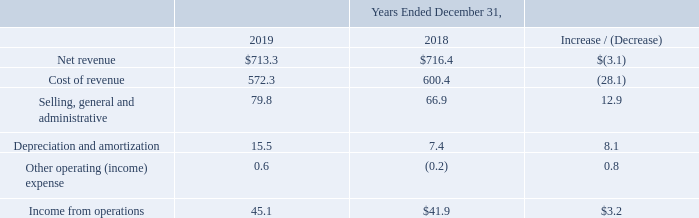Segment Results of Operations In the Company's Consolidated Financial Statements, other operating (income) expense includes (i) (gain) loss on sale or disposal of assets, (ii) lease termination costs, (iii) asset impairment expense, (iv) accretion of asset retirement obligations, and (v) FCC reimbursements. Each table summarizes the results of operations of our operating segments and compares the amount of the change between the periods presented (in millions).
Net revenue: Net revenue from our Construction segment for the year ended December 31, 2019 decreased $3.1 million to $713.3 million from $716.4 million for the year ended December 31, 2018. The decrease was primarily driven by lower revenues from our structural steel fabrication and erection business, which had increased activity in the comparable period on certain large commercial construction projects that are now at or near completion in the current period. This was largely offset by DBMG’s acquisition of GrayWolf, which was acquired late in the fourth quarter of 2018, and from higher revenues from our construction modeling and detailing business as a result of an increase in project work.
Cost of revenue: Cost of revenue from our Construction segment for the year ended December 31, 2019 decreased $28.1 million to $572.3 million from $600.4 million for the year ended December 31, 2018. The decrease was primarily driven by the timing of project activity on certain large commercial construction projects that are now at or near completion in the current period. This was partially offset by costs associated with the construction modeling and detailing business as a result of an increase in project work and increases as a result of the acquisition of GrayWolf, which was acquired late in the fourth quarter of 2018.
Selling, general and administrative: Selling, general and administrative expenses from our Construction segment for the year ended December 31, 2019 increased $12.9 million to $79.8 million from $66.9 million for the year ended December 31, 2018. The increase was primarily due to headcount-driven increases in salary and benefits and an increase in operating expenses as a result of the acquisition of GrayWolf, which was acquired late in the fourth quarter of 2018.
Depreciation and amortization: Depreciation and amortization from our Construction segment for the year ended December 31, 2019 increased $8.1 million to $15.5 million from $7.4 million for the year ended December 31, 2018. The increase was due to amortization of intangibles obtained through the acquisition of GrayWolf and assets placed into service in 2019.
Other operating (income) expense: Other operating (income) expense from our Construction segment for the year ended December 31, 2019 decreased by $0.8 million to a loss of $0.6 million from income of $0.2 million for the year ended December 31, 2018. The change was primarily due to the gains and losses on the sale of land and assets in the comparable periods.
What was the net revenue from Marine Services segment for the year ended December 31, 2019? $713.3 million. What was the net revenue from Marine Services segment for the year ended December 31, 2018? $716.4 million. What was the cost of revenue from Marine Services segment for the year ended December 31, 2019? $572.3 million. What was the percentage increase / (decrease) in the net revenue from 2018 to 2019?
Answer scale should be: percent. 713.3 / 716.4 - 1
Answer: -0.43. What was the average cost of revenue?
Answer scale should be: million. (572.3 + 600.4) / 2
Answer: 586.35. What is the percentage increase / (decrease) in the Depreciation and amortization from 2018 to 2019?
Answer scale should be: percent. (15.5 / 7.4 - 1)
Answer: 109.46. 